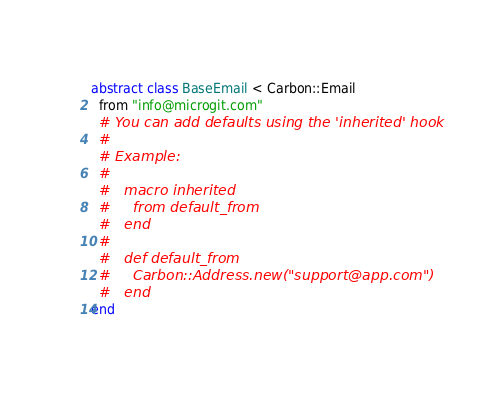<code> <loc_0><loc_0><loc_500><loc_500><_Crystal_>abstract class BaseEmail < Carbon::Email
  from "info@microgit.com"
  # You can add defaults using the 'inherited' hook
  #
  # Example:
  #
  #   macro inherited
  #     from default_from
  #   end
  #
  #   def default_from
  #     Carbon::Address.new("support@app.com")
  #   end
end
</code> 